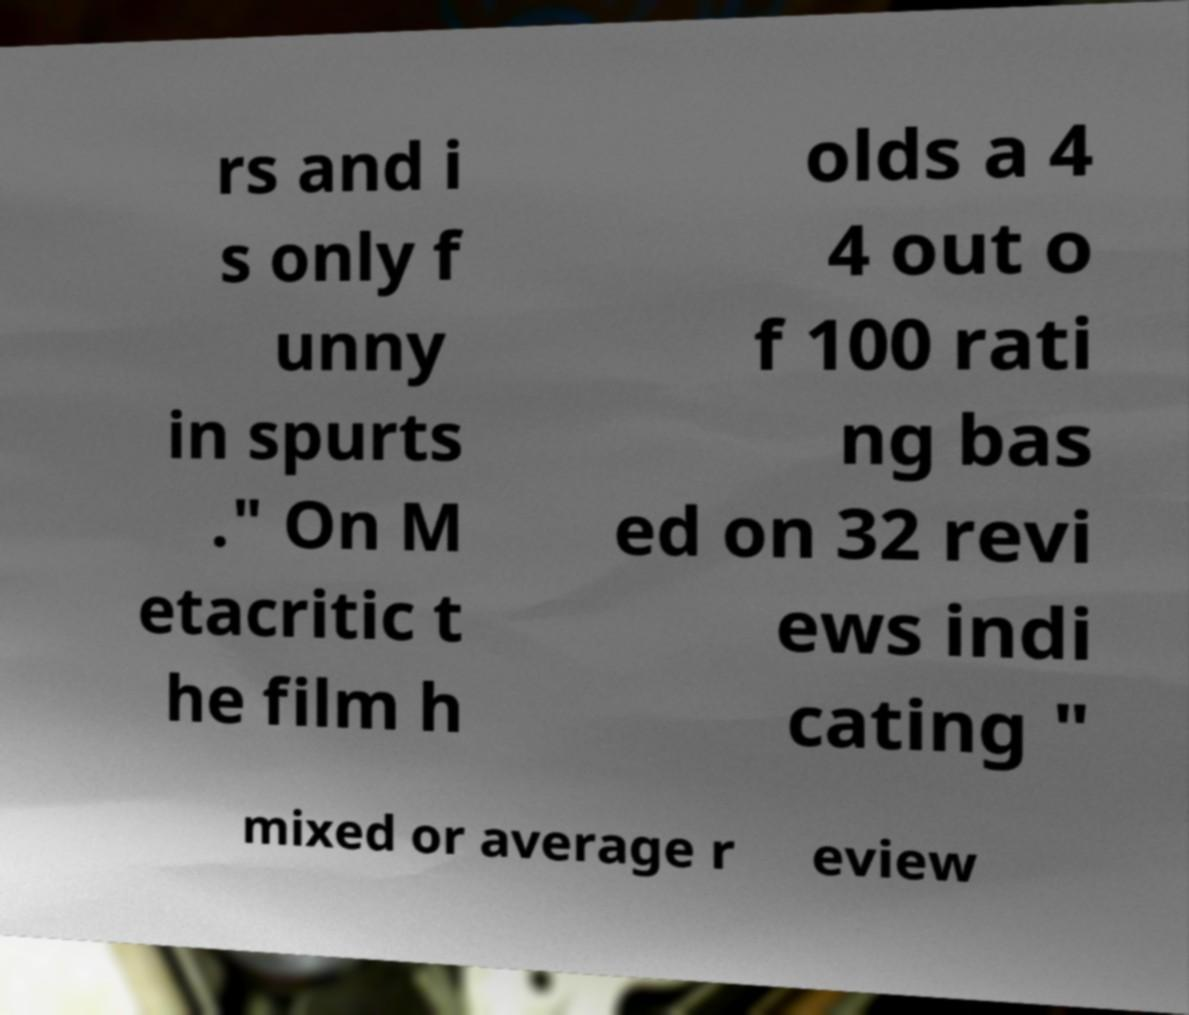Please identify and transcribe the text found in this image. rs and i s only f unny in spurts ." On M etacritic t he film h olds a 4 4 out o f 100 rati ng bas ed on 32 revi ews indi cating " mixed or average r eview 